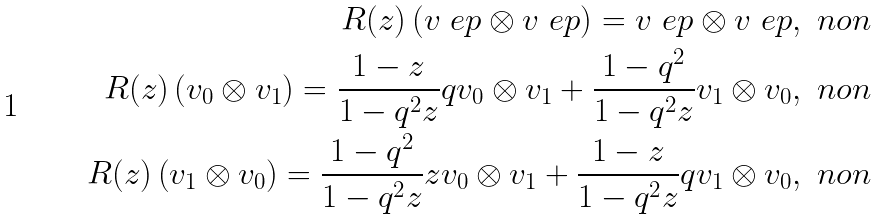<formula> <loc_0><loc_0><loc_500><loc_500>R ( z ) \left ( v _ { \ } e p \otimes v _ { \ } e p \right ) = v _ { \ } e p \otimes v _ { \ } e p , \ n o n \\ R ( z ) \left ( v _ { 0 } \otimes v _ { 1 } \right ) = \frac { 1 - z } { 1 - q ^ { 2 } z } q v _ { 0 } \otimes v _ { 1 } + \frac { 1 - q ^ { 2 } } { 1 - q ^ { 2 } z } v _ { 1 } \otimes v _ { 0 } , \ n o n \\ R ( z ) \left ( v _ { 1 } \otimes v _ { 0 } \right ) = \frac { 1 - q ^ { 2 } } { 1 - q ^ { 2 } z } z v _ { 0 } \otimes v _ { 1 } + \frac { 1 - z } { 1 - q ^ { 2 } z } q v _ { 1 } \otimes v _ { 0 } , \ n o n</formula> 